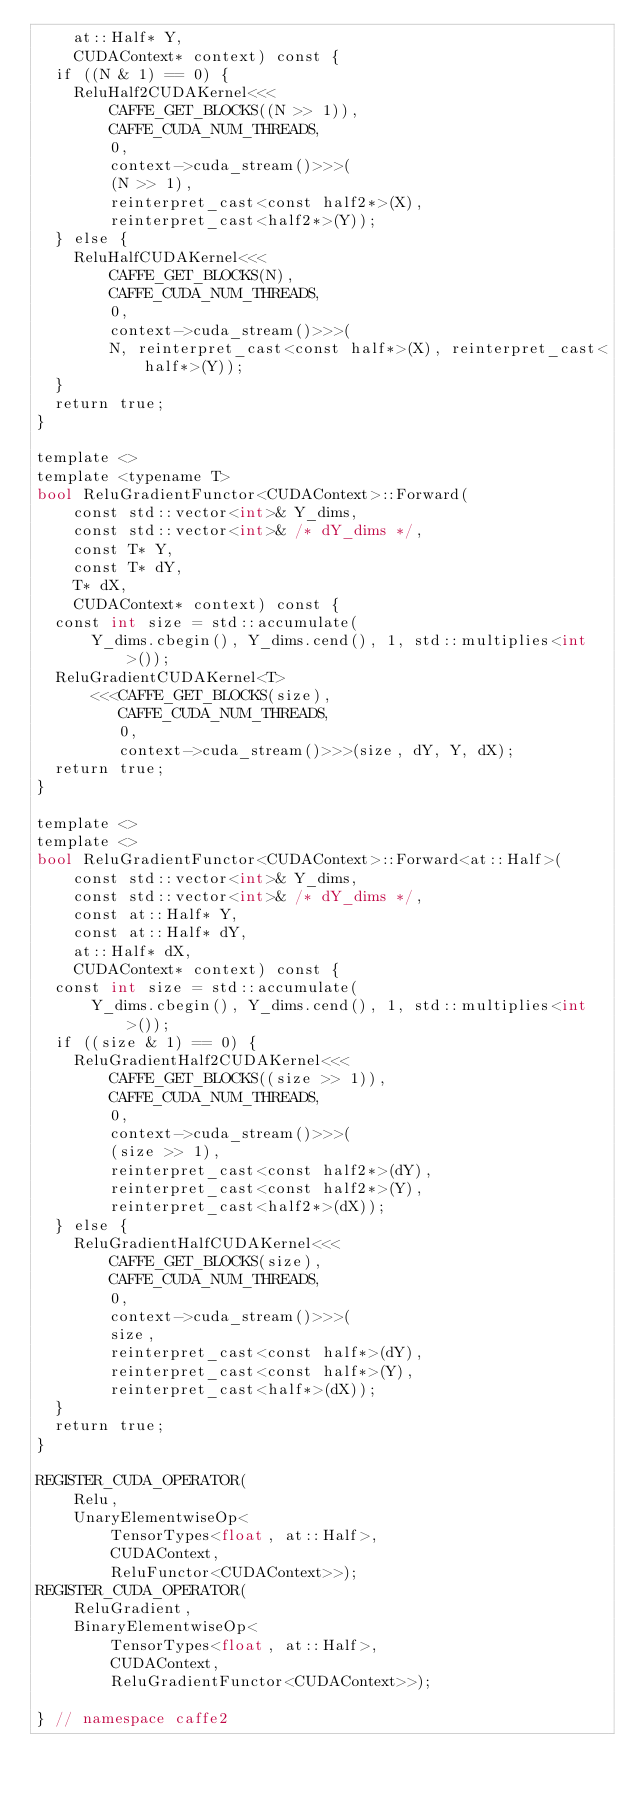Convert code to text. <code><loc_0><loc_0><loc_500><loc_500><_Cuda_>    at::Half* Y,
    CUDAContext* context) const {
  if ((N & 1) == 0) {
    ReluHalf2CUDAKernel<<<
        CAFFE_GET_BLOCKS((N >> 1)),
        CAFFE_CUDA_NUM_THREADS,
        0,
        context->cuda_stream()>>>(
        (N >> 1),
        reinterpret_cast<const half2*>(X),
        reinterpret_cast<half2*>(Y));
  } else {
    ReluHalfCUDAKernel<<<
        CAFFE_GET_BLOCKS(N),
        CAFFE_CUDA_NUM_THREADS,
        0,
        context->cuda_stream()>>>(
        N, reinterpret_cast<const half*>(X), reinterpret_cast<half*>(Y));
  }
  return true;
}

template <>
template <typename T>
bool ReluGradientFunctor<CUDAContext>::Forward(
    const std::vector<int>& Y_dims,
    const std::vector<int>& /* dY_dims */,
    const T* Y,
    const T* dY,
    T* dX,
    CUDAContext* context) const {
  const int size = std::accumulate(
      Y_dims.cbegin(), Y_dims.cend(), 1, std::multiplies<int>());
  ReluGradientCUDAKernel<T>
      <<<CAFFE_GET_BLOCKS(size),
         CAFFE_CUDA_NUM_THREADS,
         0,
         context->cuda_stream()>>>(size, dY, Y, dX);
  return true;
}

template <>
template <>
bool ReluGradientFunctor<CUDAContext>::Forward<at::Half>(
    const std::vector<int>& Y_dims,
    const std::vector<int>& /* dY_dims */,
    const at::Half* Y,
    const at::Half* dY,
    at::Half* dX,
    CUDAContext* context) const {
  const int size = std::accumulate(
      Y_dims.cbegin(), Y_dims.cend(), 1, std::multiplies<int>());
  if ((size & 1) == 0) {
    ReluGradientHalf2CUDAKernel<<<
        CAFFE_GET_BLOCKS((size >> 1)),
        CAFFE_CUDA_NUM_THREADS,
        0,
        context->cuda_stream()>>>(
        (size >> 1),
        reinterpret_cast<const half2*>(dY),
        reinterpret_cast<const half2*>(Y),
        reinterpret_cast<half2*>(dX));
  } else {
    ReluGradientHalfCUDAKernel<<<
        CAFFE_GET_BLOCKS(size),
        CAFFE_CUDA_NUM_THREADS,
        0,
        context->cuda_stream()>>>(
        size,
        reinterpret_cast<const half*>(dY),
        reinterpret_cast<const half*>(Y),
        reinterpret_cast<half*>(dX));
  }
  return true;
}

REGISTER_CUDA_OPERATOR(
    Relu,
    UnaryElementwiseOp<
        TensorTypes<float, at::Half>,
        CUDAContext,
        ReluFunctor<CUDAContext>>);
REGISTER_CUDA_OPERATOR(
    ReluGradient,
    BinaryElementwiseOp<
        TensorTypes<float, at::Half>,
        CUDAContext,
        ReluGradientFunctor<CUDAContext>>);

} // namespace caffe2
</code> 